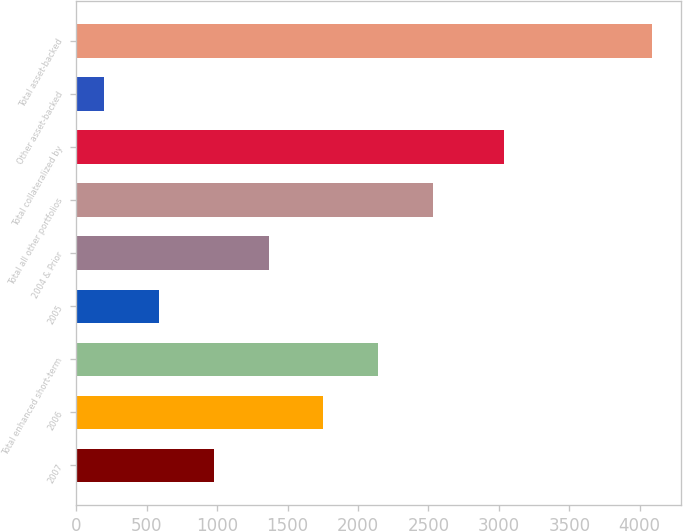Convert chart to OTSL. <chart><loc_0><loc_0><loc_500><loc_500><bar_chart><fcel>2007<fcel>2006<fcel>Total enhanced short-term<fcel>2005<fcel>2004 & Prior<fcel>Total all other portfolios<fcel>Total collateralized by<fcel>Other asset-backed<fcel>Total asset-backed<nl><fcel>975.8<fcel>1754.6<fcel>2144<fcel>586.4<fcel>1365.2<fcel>2533.4<fcel>3034<fcel>197<fcel>4091<nl></chart> 